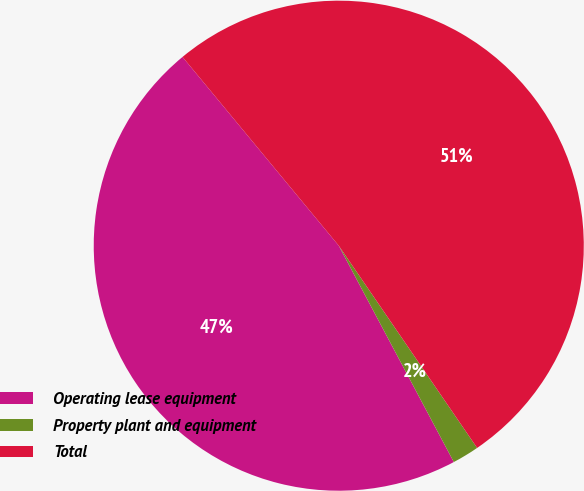Convert chart. <chart><loc_0><loc_0><loc_500><loc_500><pie_chart><fcel>Operating lease equipment<fcel>Property plant and equipment<fcel>Total<nl><fcel>46.78%<fcel>1.77%<fcel>51.46%<nl></chart> 